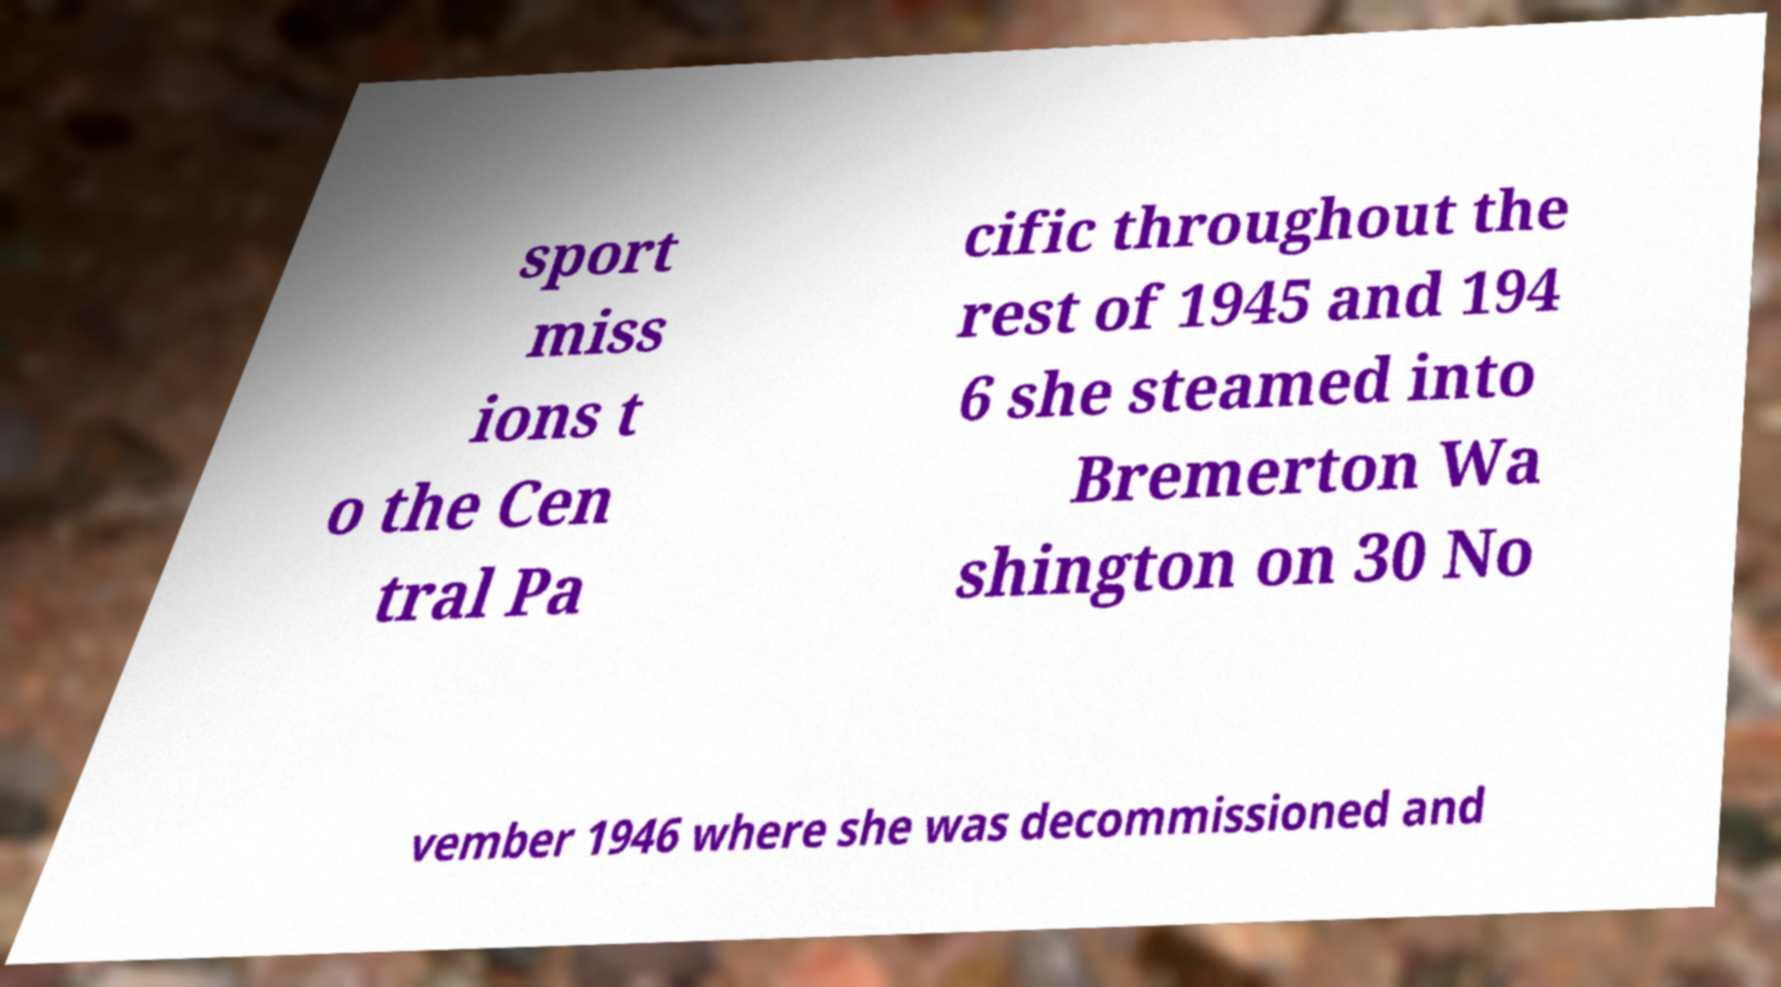Can you read and provide the text displayed in the image?This photo seems to have some interesting text. Can you extract and type it out for me? sport miss ions t o the Cen tral Pa cific throughout the rest of 1945 and 194 6 she steamed into Bremerton Wa shington on 30 No vember 1946 where she was decommissioned and 